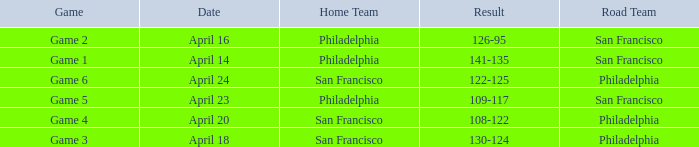On what date was game 2 played? April 16. 